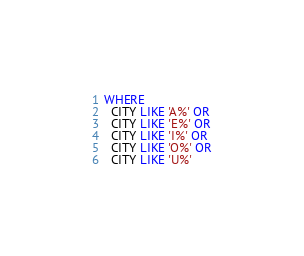<code> <loc_0><loc_0><loc_500><loc_500><_SQL_>WHERE
  CITY LIKE 'A%' OR
  CITY LIKE 'E%' OR
  CITY LIKE 'I%' OR
  CITY LIKE 'O%' OR
  CITY LIKE 'U%'</code> 